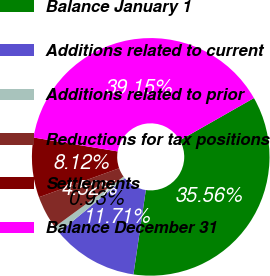Convert chart to OTSL. <chart><loc_0><loc_0><loc_500><loc_500><pie_chart><fcel>Balance January 1<fcel>Additions related to current<fcel>Additions related to prior<fcel>Reductions for tax positions<fcel>Settlements<fcel>Balance December 31<nl><fcel>35.56%<fcel>11.71%<fcel>0.93%<fcel>4.52%<fcel>8.12%<fcel>39.15%<nl></chart> 